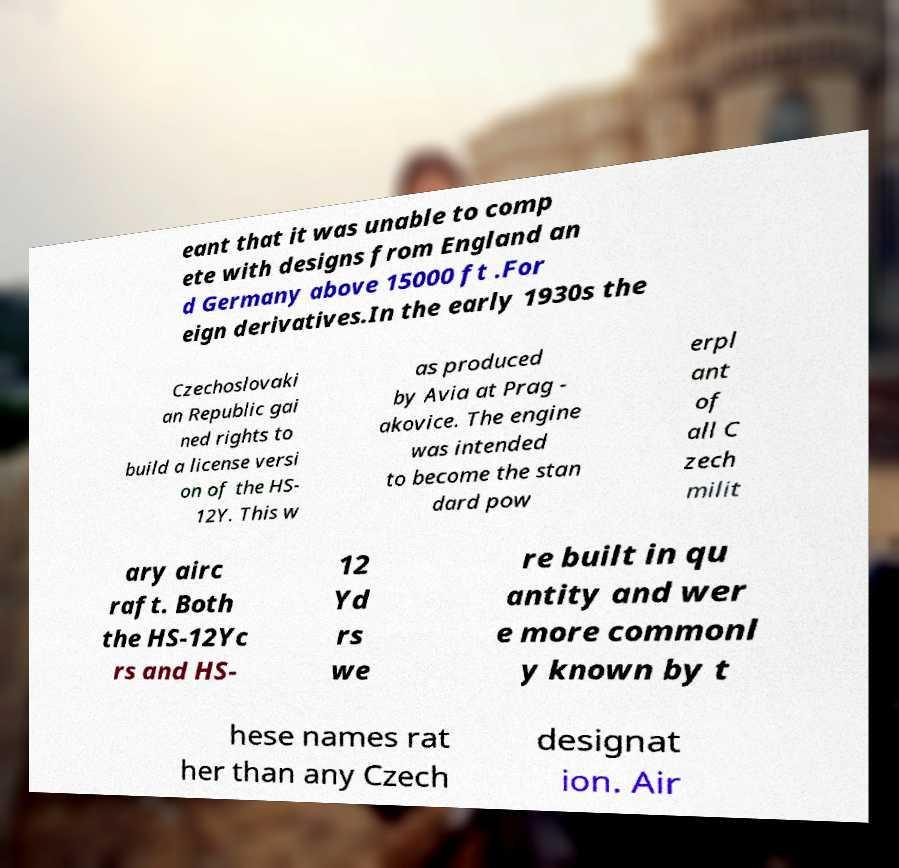Could you assist in decoding the text presented in this image and type it out clearly? eant that it was unable to comp ete with designs from England an d Germany above 15000 ft .For eign derivatives.In the early 1930s the Czechoslovaki an Republic gai ned rights to build a license versi on of the HS- 12Y. This w as produced by Avia at Prag - akovice. The engine was intended to become the stan dard pow erpl ant of all C zech milit ary airc raft. Both the HS-12Yc rs and HS- 12 Yd rs we re built in qu antity and wer e more commonl y known by t hese names rat her than any Czech designat ion. Air 